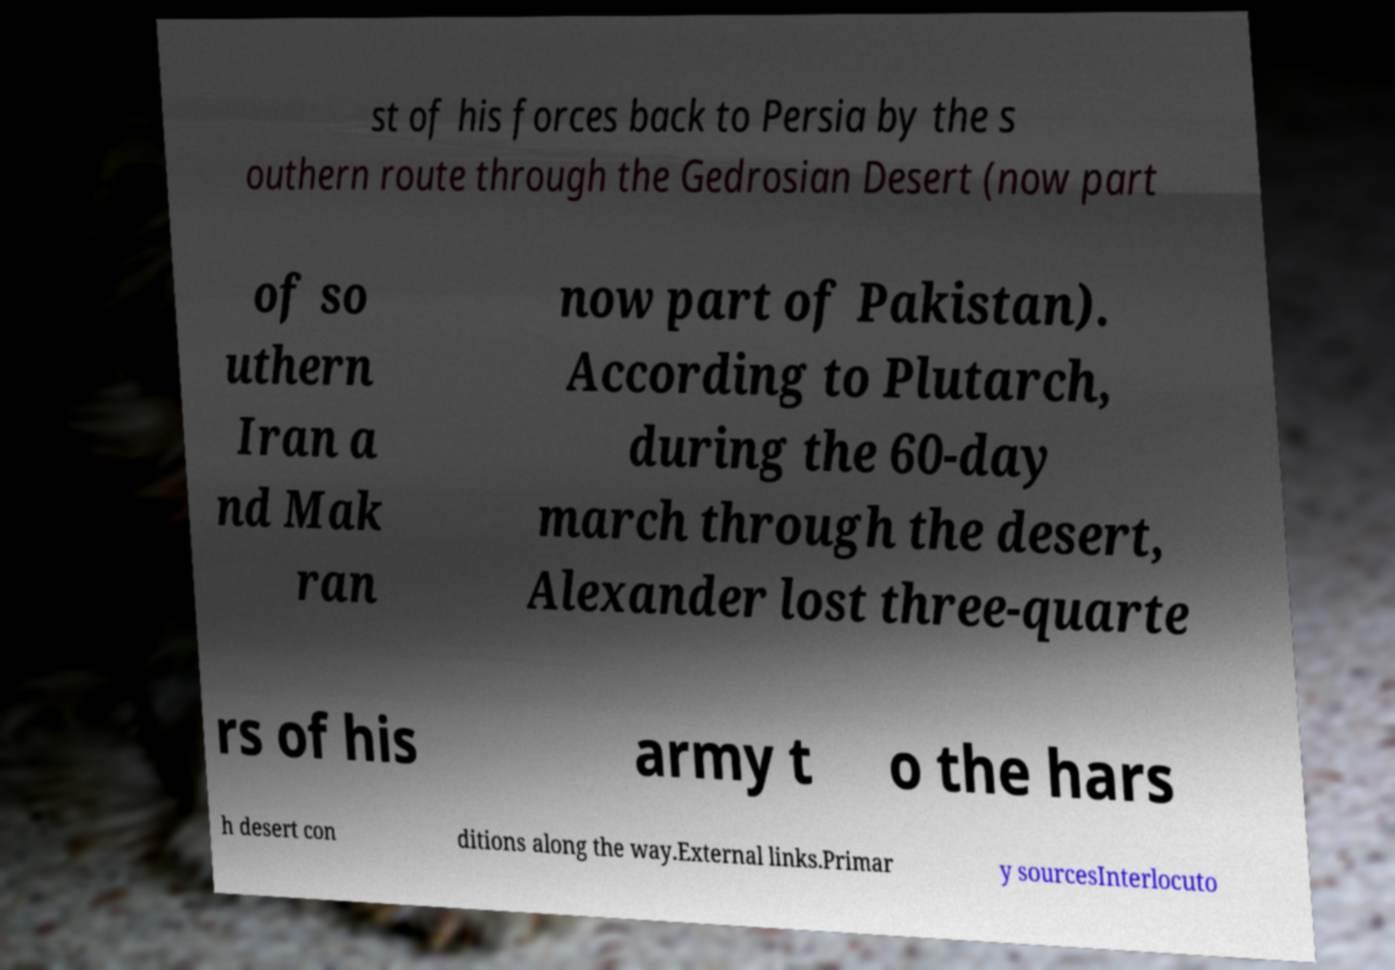Could you assist in decoding the text presented in this image and type it out clearly? st of his forces back to Persia by the s outhern route through the Gedrosian Desert (now part of so uthern Iran a nd Mak ran now part of Pakistan). According to Plutarch, during the 60-day march through the desert, Alexander lost three-quarte rs of his army t o the hars h desert con ditions along the way.External links.Primar y sourcesInterlocuto 